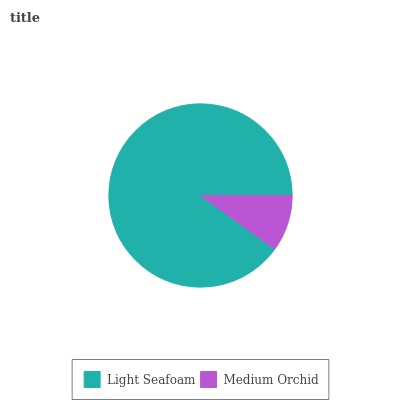Is Medium Orchid the minimum?
Answer yes or no. Yes. Is Light Seafoam the maximum?
Answer yes or no. Yes. Is Medium Orchid the maximum?
Answer yes or no. No. Is Light Seafoam greater than Medium Orchid?
Answer yes or no. Yes. Is Medium Orchid less than Light Seafoam?
Answer yes or no. Yes. Is Medium Orchid greater than Light Seafoam?
Answer yes or no. No. Is Light Seafoam less than Medium Orchid?
Answer yes or no. No. Is Light Seafoam the high median?
Answer yes or no. Yes. Is Medium Orchid the low median?
Answer yes or no. Yes. Is Medium Orchid the high median?
Answer yes or no. No. Is Light Seafoam the low median?
Answer yes or no. No. 